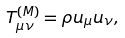<formula> <loc_0><loc_0><loc_500><loc_500>T _ { \mu \nu } ^ { ( M ) } = \rho u _ { \mu } u _ { \nu } ,</formula> 